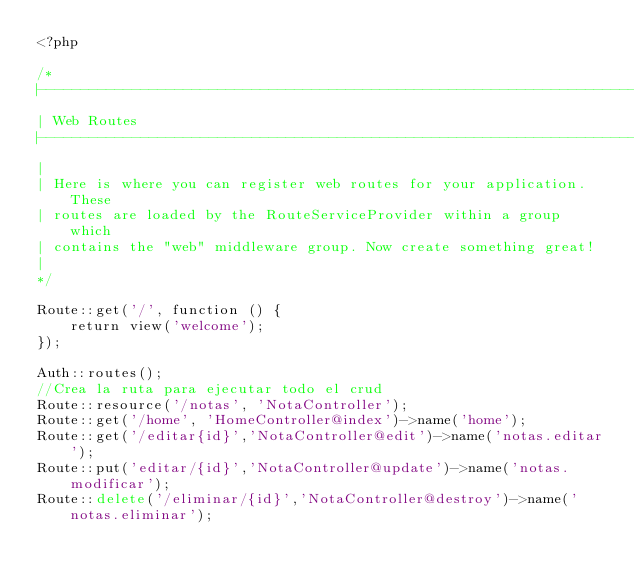Convert code to text. <code><loc_0><loc_0><loc_500><loc_500><_PHP_><?php

/*
|--------------------------------------------------------------------------
| Web Routes
|--------------------------------------------------------------------------
|
| Here is where you can register web routes for your application. These
| routes are loaded by the RouteServiceProvider within a group which
| contains the "web" middleware group. Now create something great!
|
*/

Route::get('/', function () {
    return view('welcome');
});

Auth::routes();
//Crea la ruta para ejecutar todo el crud
Route::resource('/notas', 'NotaController');
Route::get('/home', 'HomeController@index')->name('home');
Route::get('/editar{id}','NotaController@edit')->name('notas.editar');
Route::put('editar/{id}','NotaController@update')->name('notas.modificar');
Route::delete('/eliminar/{id}','NotaController@destroy')->name('notas.eliminar');
</code> 